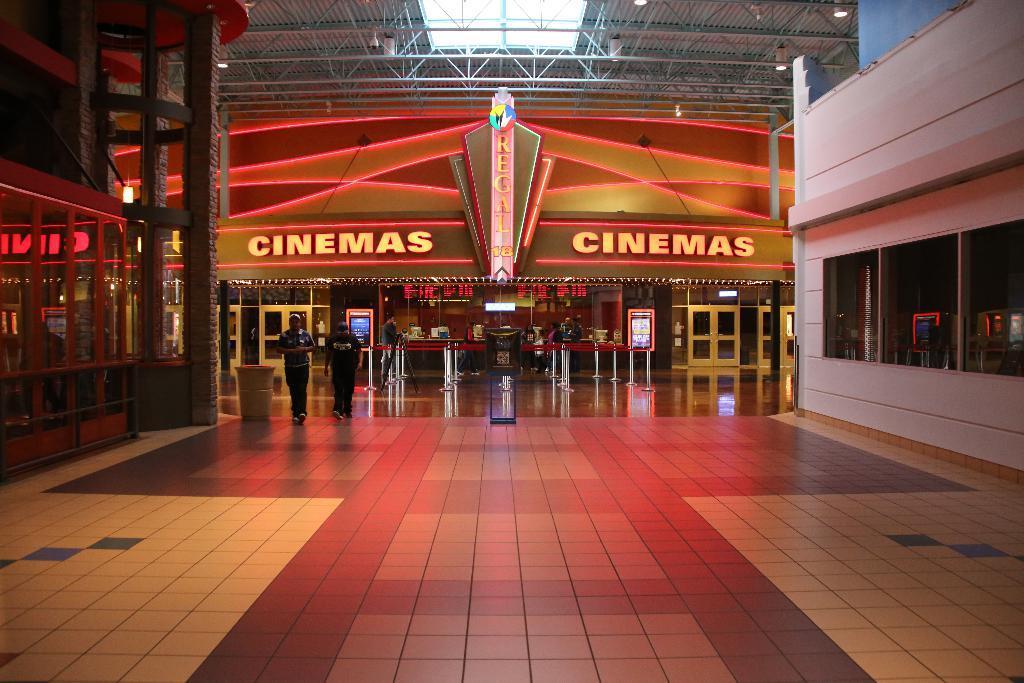Please provide a concise description of this image. This is the picture of a building, there is text on the wall. In the foreground there are two people walking. At the back there are people and there is a railing. There are screens and there are objects on the table and there are doors. At the top there are lights on the roof. At the bottom there is a floor. 